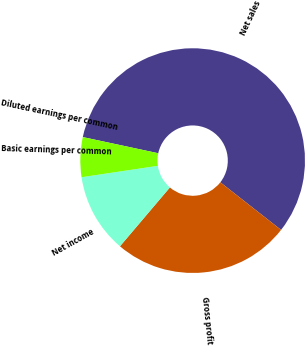Convert chart to OTSL. <chart><loc_0><loc_0><loc_500><loc_500><pie_chart><fcel>Net sales<fcel>Gross profit<fcel>Net income<fcel>Basic earnings per common<fcel>Diluted earnings per common<nl><fcel>57.22%<fcel>25.62%<fcel>11.44%<fcel>5.72%<fcel>0.0%<nl></chart> 